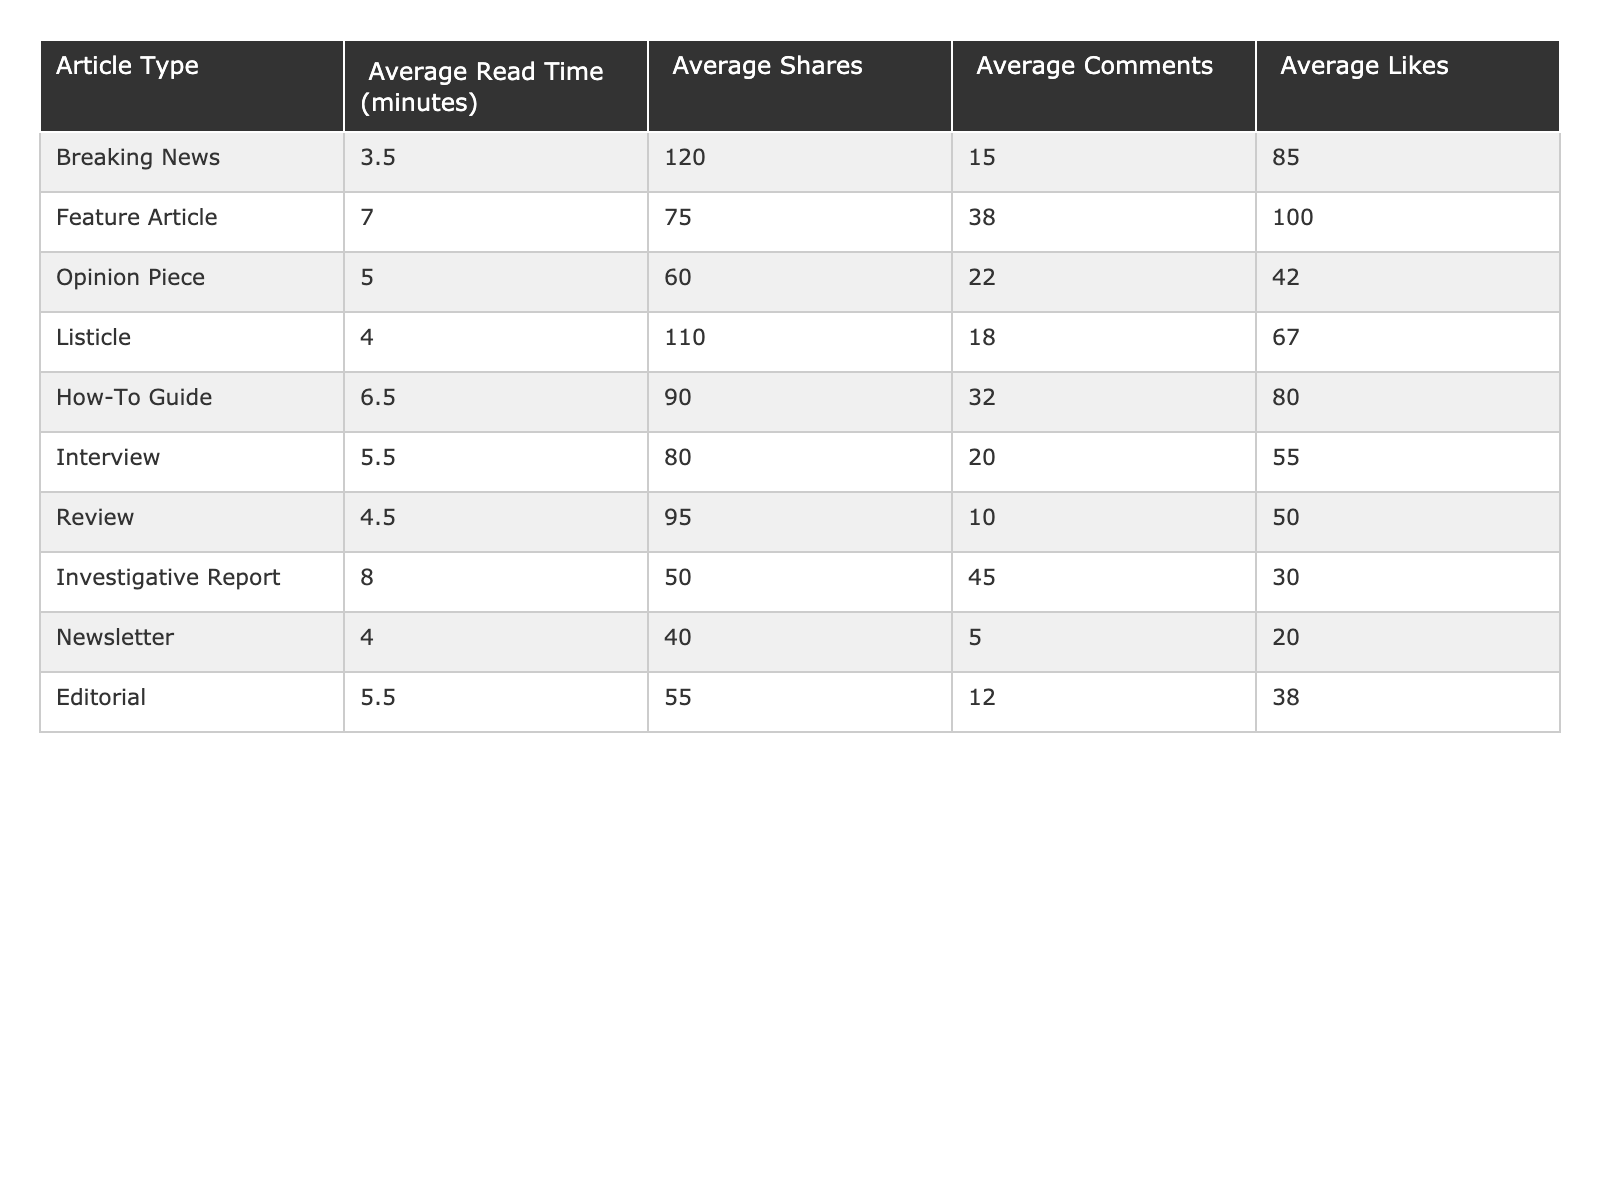What's the average read time for a Feature Article? The table shows that the average read time for a Feature Article is 7.0 minutes directly listed under that category.
Answer: 7.0 minutes Which article type has the highest average shares? Looking at the Average Shares column, "Breaking News" has the highest value at 120 shares compared to the other article types.
Answer: Breaking News What is the total average comments for Listicle and How-To Guide combined? The average comments for Listicle is 18 and for How-To Guide is 32. Adding them gives 18 + 32 = 50.
Answer: 50 Is the average read time for Opinion Pieces greater than that for Interviews? The average read time for Opinion Pieces is 5.0 minutes and for Interviews is 5.5 minutes. Since 5.0 is not greater than 5.5, the statement is false.
Answer: No Which article types have an average like count greater than 70? From the Average Likes column, the article types "Feature Article" (100), "How-To Guide" (80), and "Listicle" (67) have like counts greater than 70, while "Breaking News" (85) also exceeds this. This gives four article types in total.
Answer: 4 What is the difference in average read time between Investigative Reports and Breaking News? Investigative Reports have an average read time of 8.0 minutes and Breaking News has 3.5 minutes. The difference is 8.0 - 3.5 = 4.5 minutes.
Answer: 4.5 minutes Which article type has the least average comments, and what is that value? Scanning the Average Comments column, the article type "Newsletter" has the least average comments with a value of 5.
Answer: Newsletter, 5 If we consider the sum of average likes for all article types, what is the result? Adding the average likes: 85 (Breaking News) + 100 (Feature Article) + 42 (Opinion Piece) + 67 (Listicle) + 80 (How-To Guide) + 55 (Interview) + 50 (Review) + 30 (Investigative Report) + 20 (Newsletter) + 38 (Editorial) gives a total of  70 + 360 = 602.
Answer: 602 Are average shares for "Review" and "Newsletter" both below 60? The average shares for Review is 95 and for Newsletter is 40. Since 95 is above 60, the statement is false.
Answer: No What is the article type with the second-highest average likes, and what is that value? By examining the Average Likes column, Feature Article has the highest at 100 and How-To Guide is the second-highest with 80.
Answer: How-To Guide, 80 